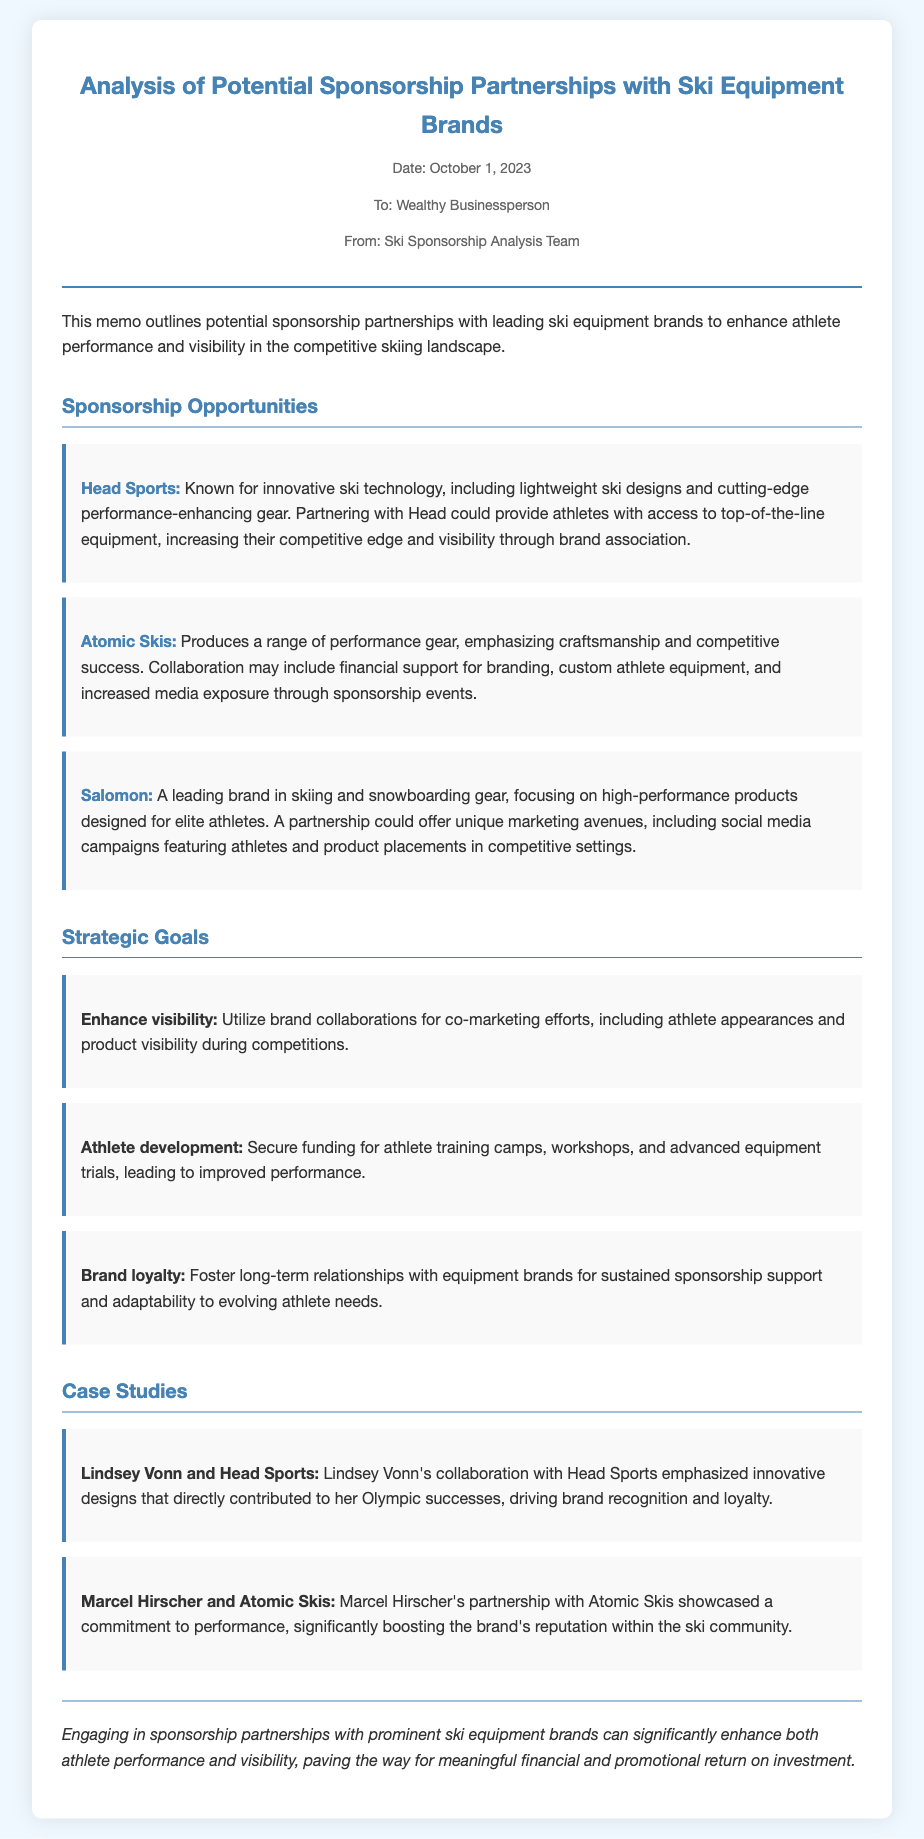What is the date of the memo? The date is prominently listed at the top of the memo, indicating when it was created.
Answer: October 1, 2023 Who is the recipient of the memo? The memo specifies to whom it is addressed, identifying the individual or group receiving this information.
Answer: Wealthy Businessperson Which brand is known for innovative ski technology? The document highlights specific brands and their specialties, including one recognized for innovative designs.
Answer: Head Sports What is one of the strategic goals mentioned? The document outlines several strategic goals, focusing on various aspects of sponsorship opportunities.
Answer: Enhance visibility Which athlete is associated with Atomic Skis? The memo provides case studies of specific athletes and their partnerships with equipment brands, including one clearly linked to Atomic Skis.
Answer: Marcel Hirscher What type of document is this? The structure and content focus on analyzing sponsorship partnerships, suggesting a specific format for business communication.
Answer: Memo How many sponsorship opportunities are mentioned? The opportunities section lists individual brands, providing a count of those noted in the document.
Answer: Three What is the conclusion about sponsorship partnerships? The final thoughts summarize the findings and implications drawn from the analysis presented throughout the memo.
Answer: Enhance both athlete performance and visibility 